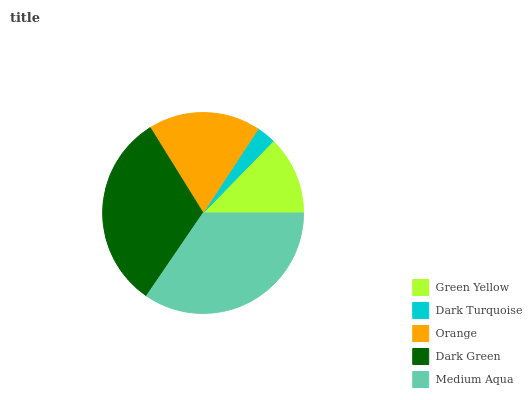Is Dark Turquoise the minimum?
Answer yes or no. Yes. Is Medium Aqua the maximum?
Answer yes or no. Yes. Is Orange the minimum?
Answer yes or no. No. Is Orange the maximum?
Answer yes or no. No. Is Orange greater than Dark Turquoise?
Answer yes or no. Yes. Is Dark Turquoise less than Orange?
Answer yes or no. Yes. Is Dark Turquoise greater than Orange?
Answer yes or no. No. Is Orange less than Dark Turquoise?
Answer yes or no. No. Is Orange the high median?
Answer yes or no. Yes. Is Orange the low median?
Answer yes or no. Yes. Is Dark Green the high median?
Answer yes or no. No. Is Green Yellow the low median?
Answer yes or no. No. 